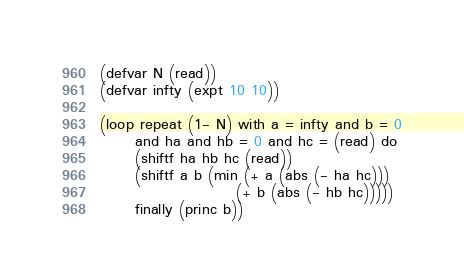<code> <loc_0><loc_0><loc_500><loc_500><_Lisp_>(defvar N (read))
(defvar infty (expt 10 10))

(loop repeat (1- N) with a = infty and b = 0
      and ha and hb = 0 and hc = (read) do
      (shiftf ha hb hc (read))
      (shiftf a b (min (+ a (abs (- ha hc)))
                       (+ b (abs (- hb hc)))))
      finally (princ b))
</code> 